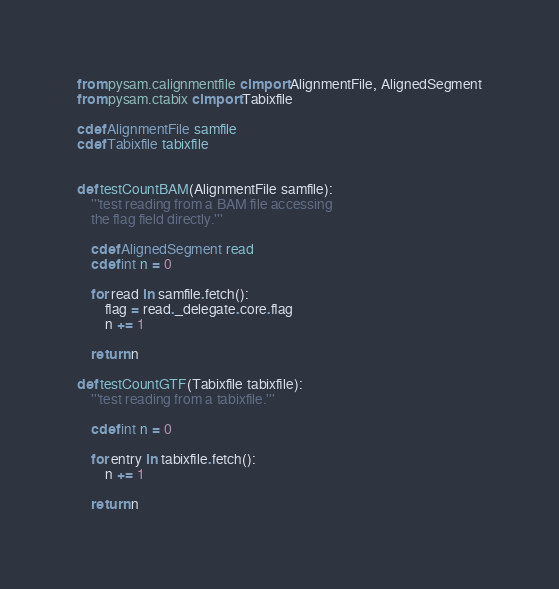Convert code to text. <code><loc_0><loc_0><loc_500><loc_500><_Cython_>from pysam.calignmentfile cimport AlignmentFile, AlignedSegment
from pysam.ctabix cimport Tabixfile

cdef AlignmentFile samfile
cdef Tabixfile tabixfile


def testCountBAM(AlignmentFile samfile):
    '''test reading from a BAM file accessing
    the flag field directly.'''

    cdef AlignedSegment read
    cdef int n = 0
    
    for read in samfile.fetch():
        flag = read._delegate.core.flag
        n += 1
            
    return n

def testCountGTF(Tabixfile tabixfile):
    '''test reading from a tabixfile.'''
    
    cdef int n = 0

    for entry in tabixfile.fetch():
        n += 1

    return n
</code> 